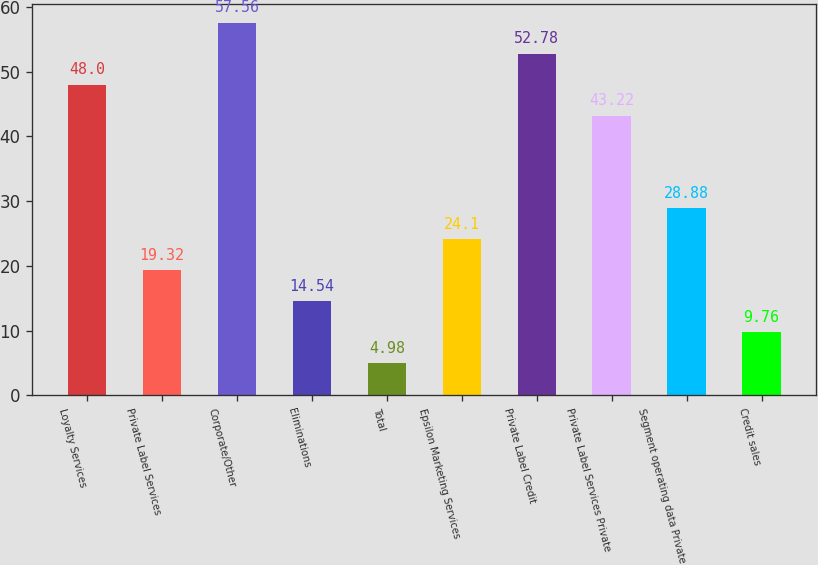Convert chart to OTSL. <chart><loc_0><loc_0><loc_500><loc_500><bar_chart><fcel>Loyalty Services<fcel>Private Label Services<fcel>Corporate/Other<fcel>Eliminations<fcel>Total<fcel>Epsilon Marketing Services<fcel>Private Label Credit<fcel>Private Label Services Private<fcel>Segment operating data Private<fcel>Credit sales<nl><fcel>48<fcel>19.32<fcel>57.56<fcel>14.54<fcel>4.98<fcel>24.1<fcel>52.78<fcel>43.22<fcel>28.88<fcel>9.76<nl></chart> 